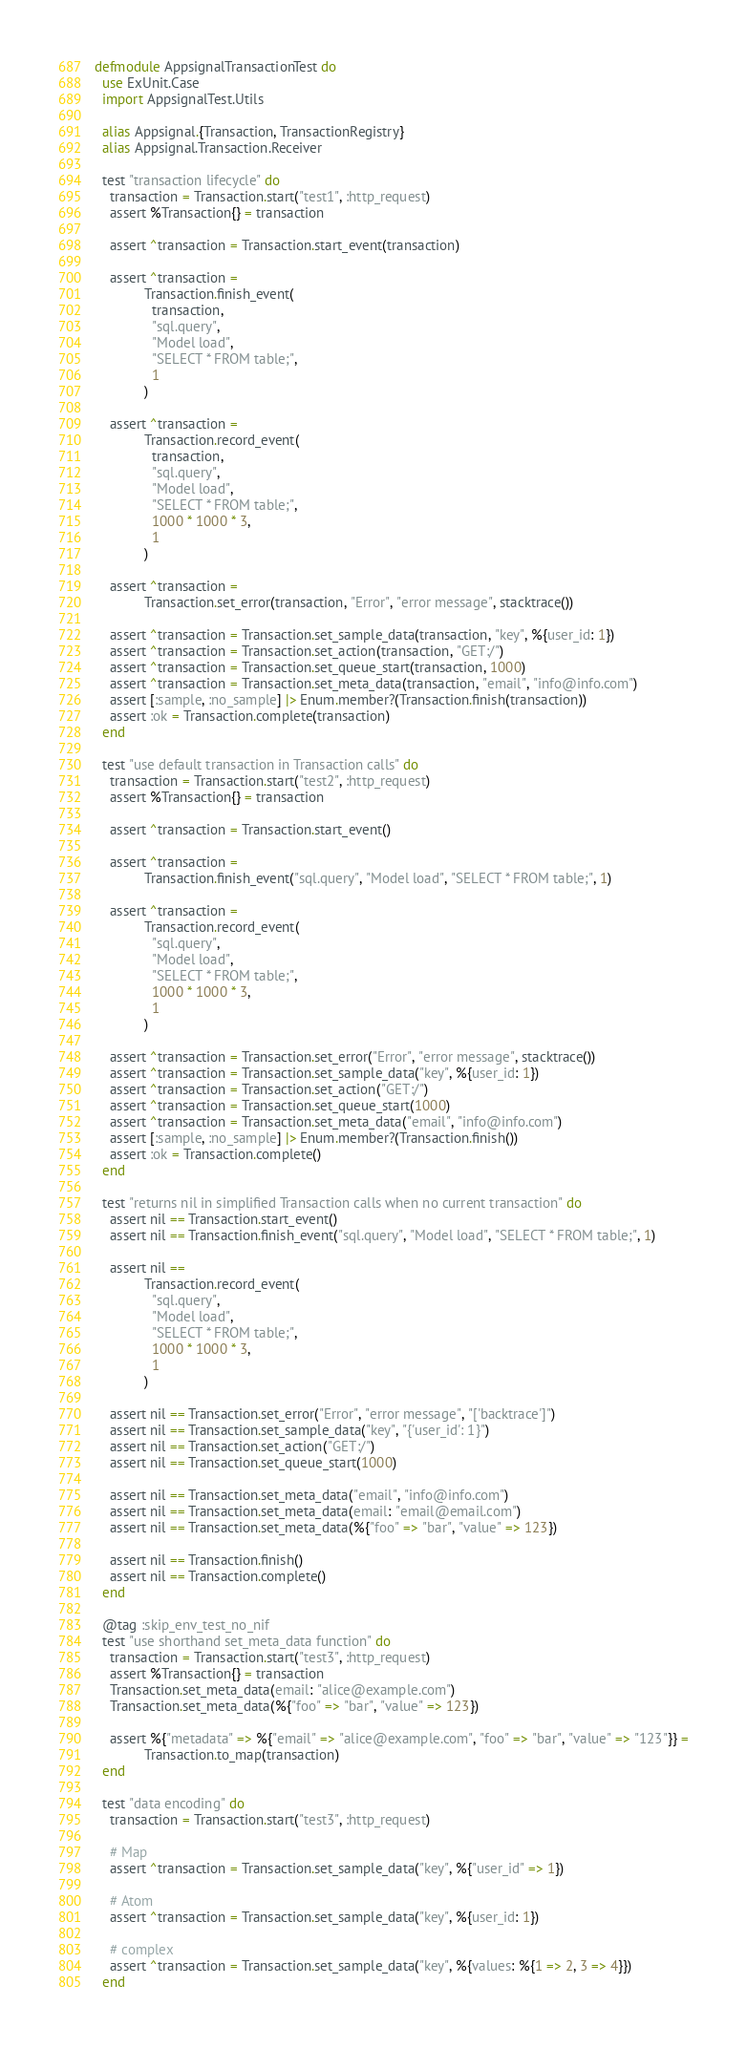Convert code to text. <code><loc_0><loc_0><loc_500><loc_500><_Elixir_>defmodule AppsignalTransactionTest do
  use ExUnit.Case
  import AppsignalTest.Utils

  alias Appsignal.{Transaction, TransactionRegistry}
  alias Appsignal.Transaction.Receiver

  test "transaction lifecycle" do
    transaction = Transaction.start("test1", :http_request)
    assert %Transaction{} = transaction

    assert ^transaction = Transaction.start_event(transaction)

    assert ^transaction =
             Transaction.finish_event(
               transaction,
               "sql.query",
               "Model load",
               "SELECT * FROM table;",
               1
             )

    assert ^transaction =
             Transaction.record_event(
               transaction,
               "sql.query",
               "Model load",
               "SELECT * FROM table;",
               1000 * 1000 * 3,
               1
             )

    assert ^transaction =
             Transaction.set_error(transaction, "Error", "error message", stacktrace())

    assert ^transaction = Transaction.set_sample_data(transaction, "key", %{user_id: 1})
    assert ^transaction = Transaction.set_action(transaction, "GET:/")
    assert ^transaction = Transaction.set_queue_start(transaction, 1000)
    assert ^transaction = Transaction.set_meta_data(transaction, "email", "info@info.com")
    assert [:sample, :no_sample] |> Enum.member?(Transaction.finish(transaction))
    assert :ok = Transaction.complete(transaction)
  end

  test "use default transaction in Transaction calls" do
    transaction = Transaction.start("test2", :http_request)
    assert %Transaction{} = transaction

    assert ^transaction = Transaction.start_event()

    assert ^transaction =
             Transaction.finish_event("sql.query", "Model load", "SELECT * FROM table;", 1)

    assert ^transaction =
             Transaction.record_event(
               "sql.query",
               "Model load",
               "SELECT * FROM table;",
               1000 * 1000 * 3,
               1
             )

    assert ^transaction = Transaction.set_error("Error", "error message", stacktrace())
    assert ^transaction = Transaction.set_sample_data("key", %{user_id: 1})
    assert ^transaction = Transaction.set_action("GET:/")
    assert ^transaction = Transaction.set_queue_start(1000)
    assert ^transaction = Transaction.set_meta_data("email", "info@info.com")
    assert [:sample, :no_sample] |> Enum.member?(Transaction.finish())
    assert :ok = Transaction.complete()
  end

  test "returns nil in simplified Transaction calls when no current transaction" do
    assert nil == Transaction.start_event()
    assert nil == Transaction.finish_event("sql.query", "Model load", "SELECT * FROM table;", 1)

    assert nil ==
             Transaction.record_event(
               "sql.query",
               "Model load",
               "SELECT * FROM table;",
               1000 * 1000 * 3,
               1
             )

    assert nil == Transaction.set_error("Error", "error message", "['backtrace']")
    assert nil == Transaction.set_sample_data("key", "{'user_id': 1}")
    assert nil == Transaction.set_action("GET:/")
    assert nil == Transaction.set_queue_start(1000)

    assert nil == Transaction.set_meta_data("email", "info@info.com")
    assert nil == Transaction.set_meta_data(email: "email@email.com")
    assert nil == Transaction.set_meta_data(%{"foo" => "bar", "value" => 123})

    assert nil == Transaction.finish()
    assert nil == Transaction.complete()
  end

  @tag :skip_env_test_no_nif
  test "use shorthand set_meta_data function" do
    transaction = Transaction.start("test3", :http_request)
    assert %Transaction{} = transaction
    Transaction.set_meta_data(email: "alice@example.com")
    Transaction.set_meta_data(%{"foo" => "bar", "value" => 123})

    assert %{"metadata" => %{"email" => "alice@example.com", "foo" => "bar", "value" => "123"}} =
             Transaction.to_map(transaction)
  end

  test "data encoding" do
    transaction = Transaction.start("test3", :http_request)

    # Map
    assert ^transaction = Transaction.set_sample_data("key", %{"user_id" => 1})

    # Atom
    assert ^transaction = Transaction.set_sample_data("key", %{user_id: 1})

    # complex
    assert ^transaction = Transaction.set_sample_data("key", %{values: %{1 => 2, 3 => 4}})
  end
</code> 